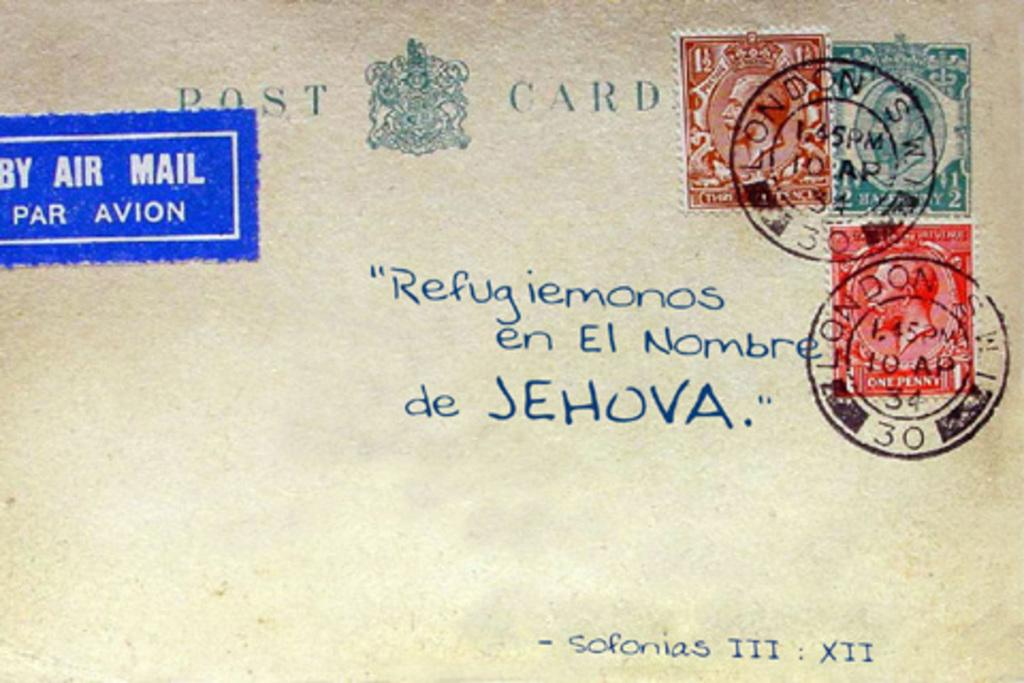<image>
Offer a succinct explanation of the picture presented. A postcard sent via air mail to someone Spanish-speaking 